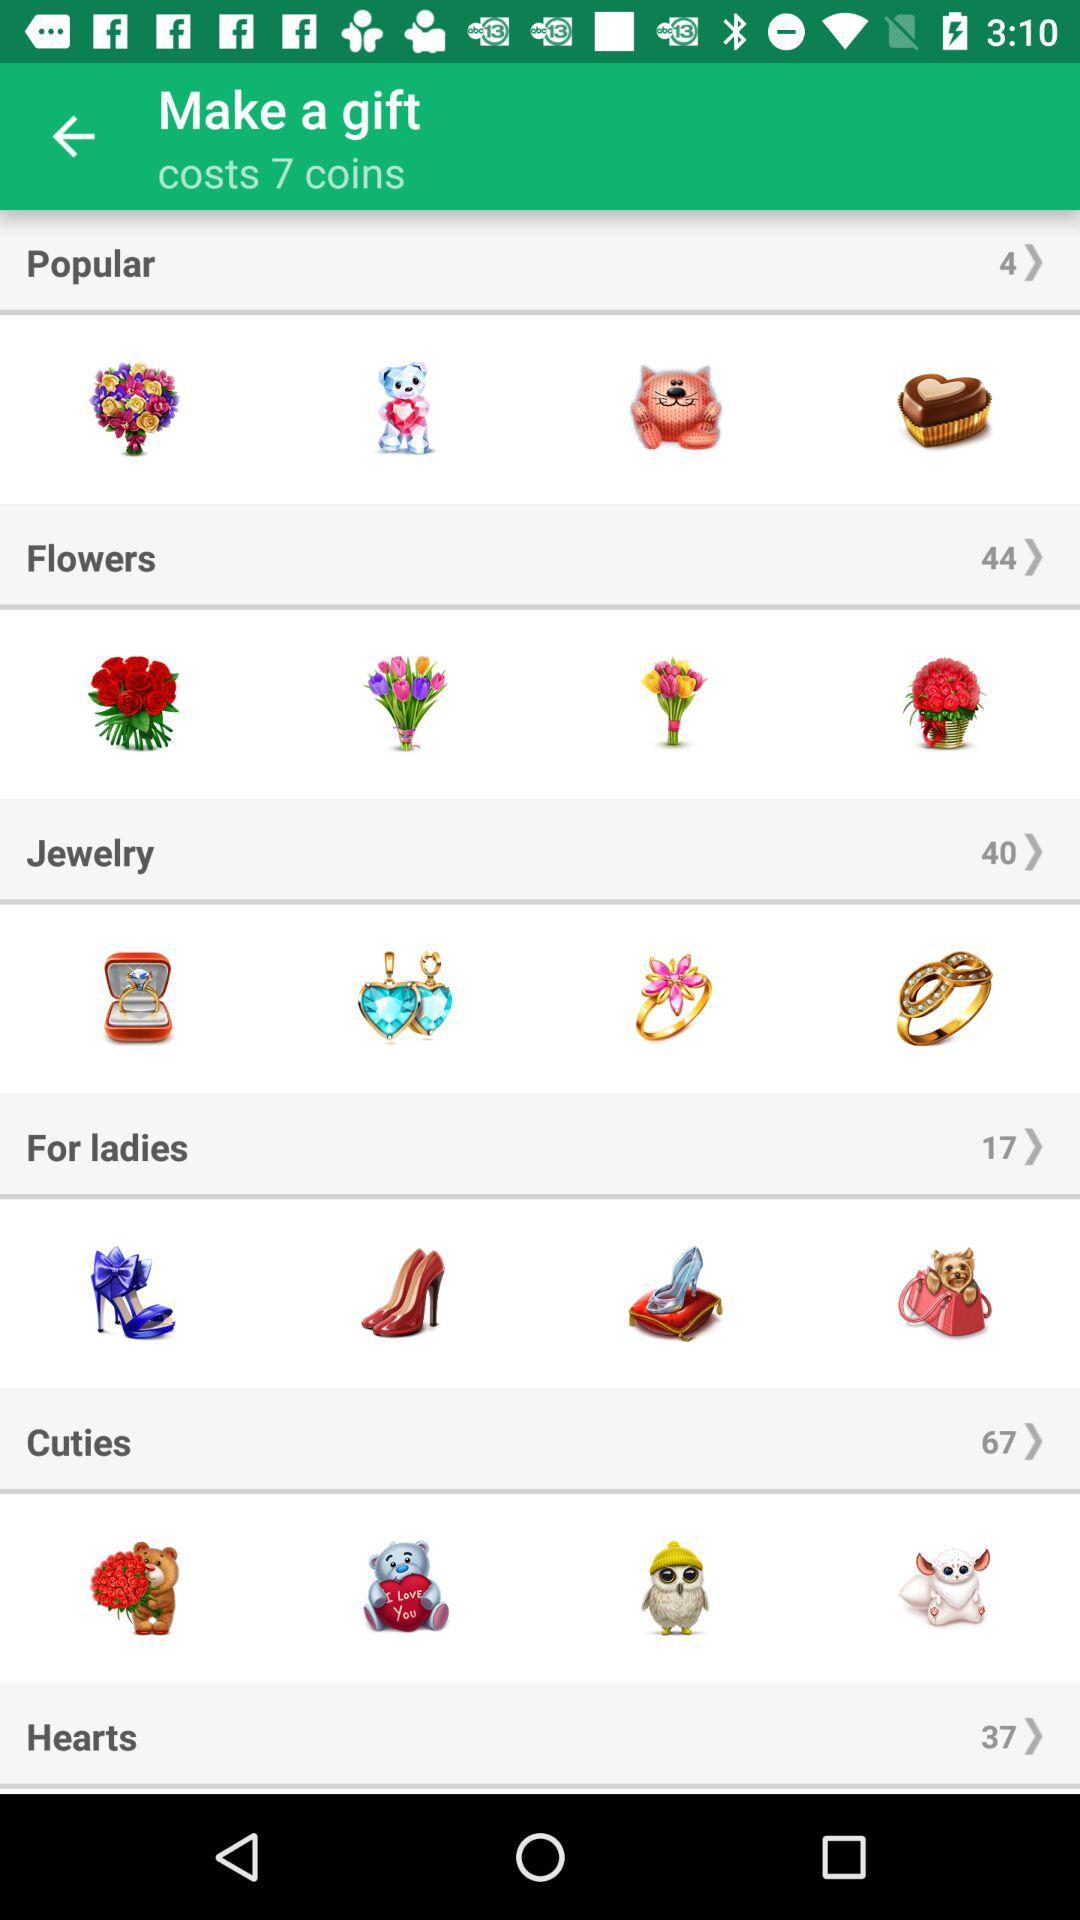Can the user afford the gift?
When the provided information is insufficient, respond with <no answer>. <no answer> 